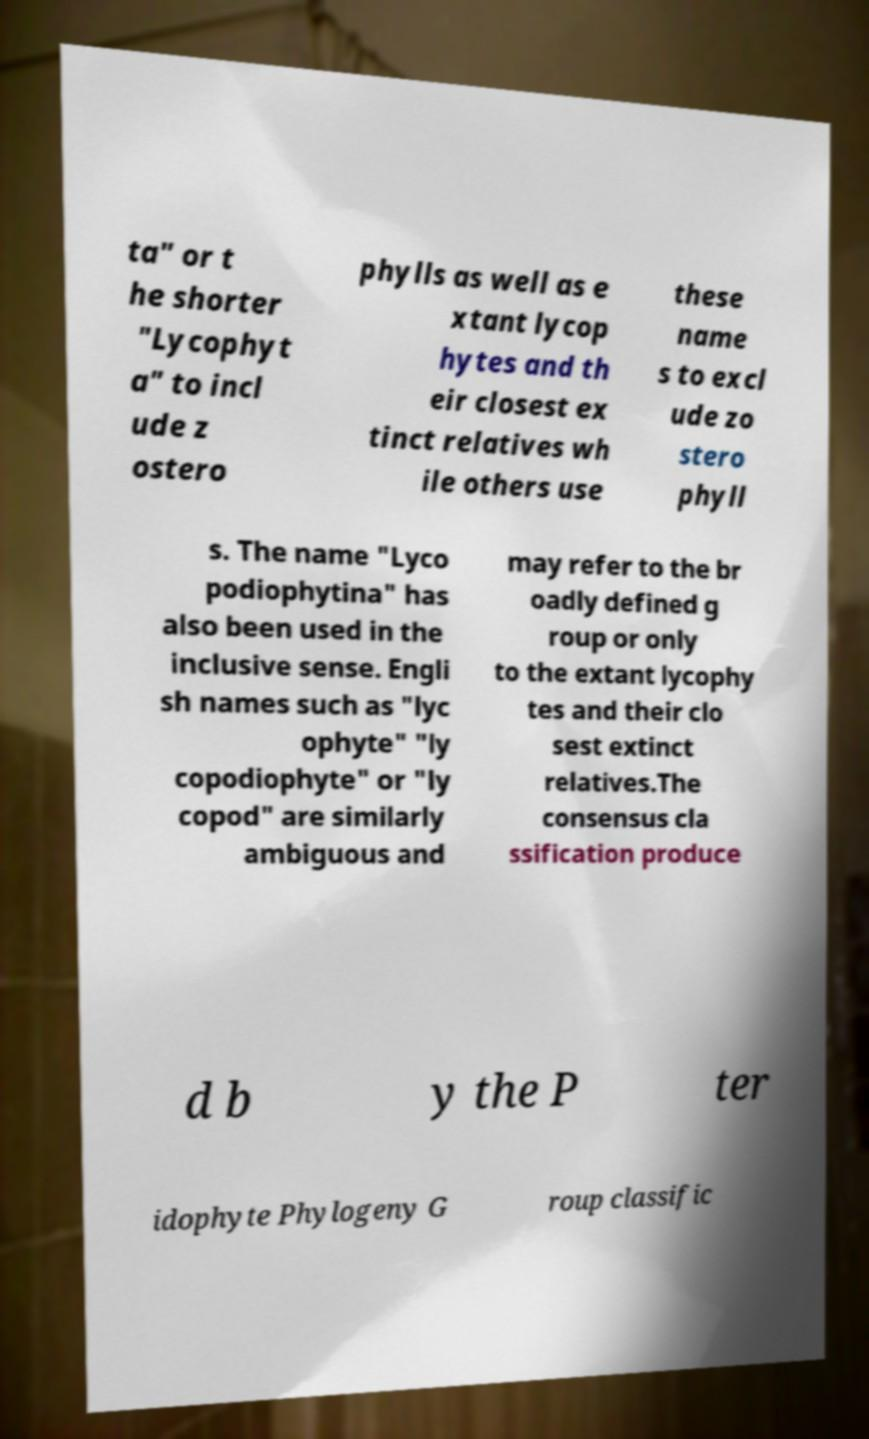I need the written content from this picture converted into text. Can you do that? ta" or t he shorter "Lycophyt a" to incl ude z ostero phylls as well as e xtant lycop hytes and th eir closest ex tinct relatives wh ile others use these name s to excl ude zo stero phyll s. The name "Lyco podiophytina" has also been used in the inclusive sense. Engli sh names such as "lyc ophyte" "ly copodiophyte" or "ly copod" are similarly ambiguous and may refer to the br oadly defined g roup or only to the extant lycophy tes and their clo sest extinct relatives.The consensus cla ssification produce d b y the P ter idophyte Phylogeny G roup classific 